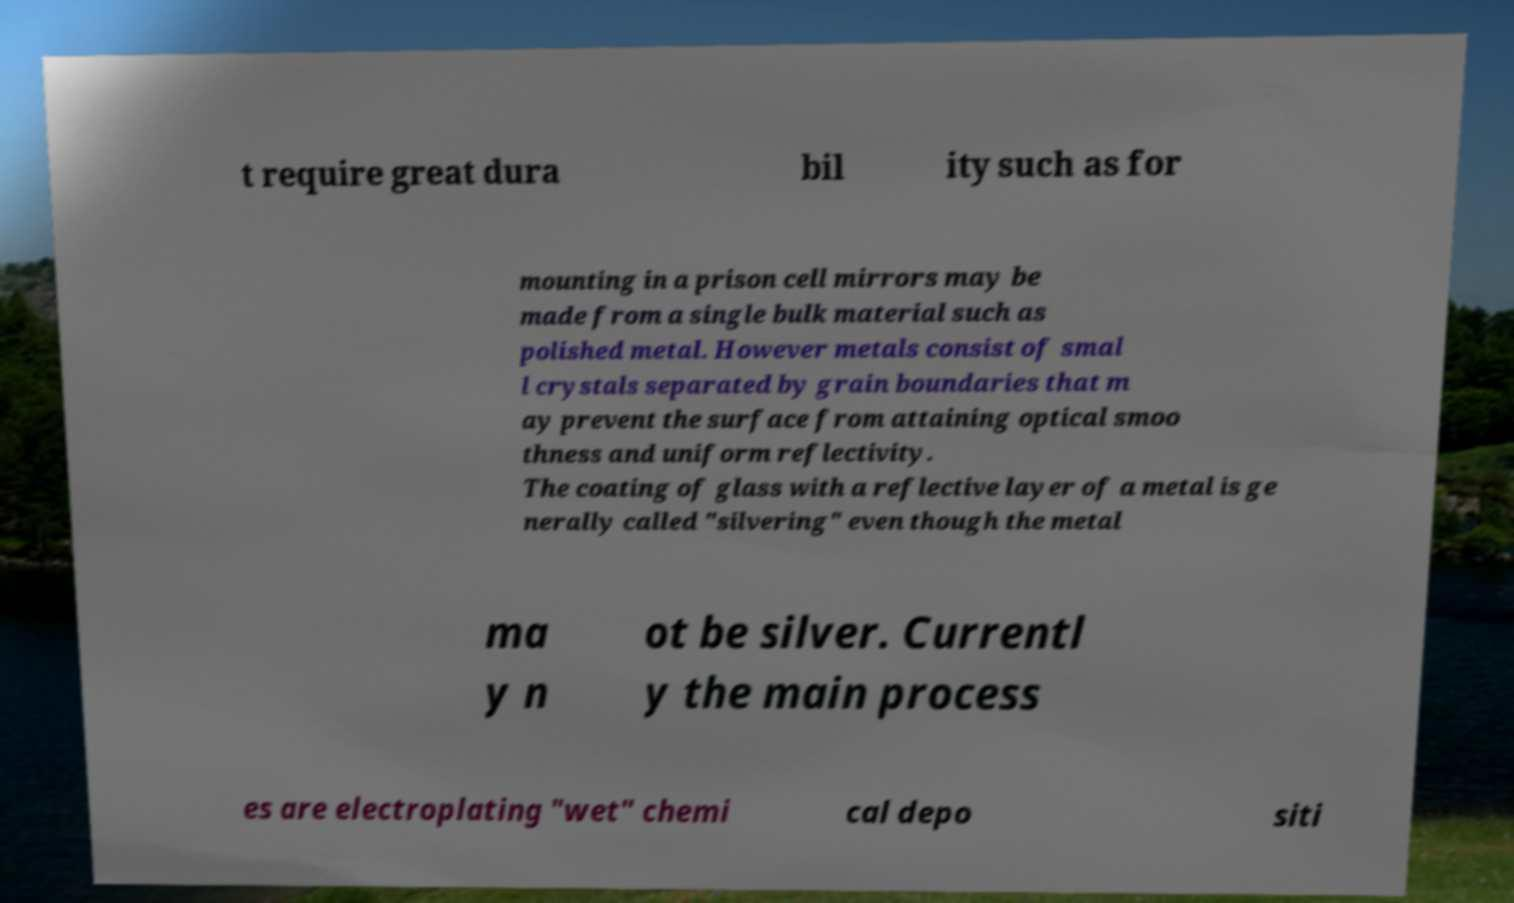Could you assist in decoding the text presented in this image and type it out clearly? t require great dura bil ity such as for mounting in a prison cell mirrors may be made from a single bulk material such as polished metal. However metals consist of smal l crystals separated by grain boundaries that m ay prevent the surface from attaining optical smoo thness and uniform reflectivity. The coating of glass with a reflective layer of a metal is ge nerally called "silvering" even though the metal ma y n ot be silver. Currentl y the main process es are electroplating "wet" chemi cal depo siti 